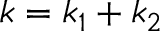<formula> <loc_0><loc_0><loc_500><loc_500>k = k _ { 1 } + k _ { 2 }</formula> 